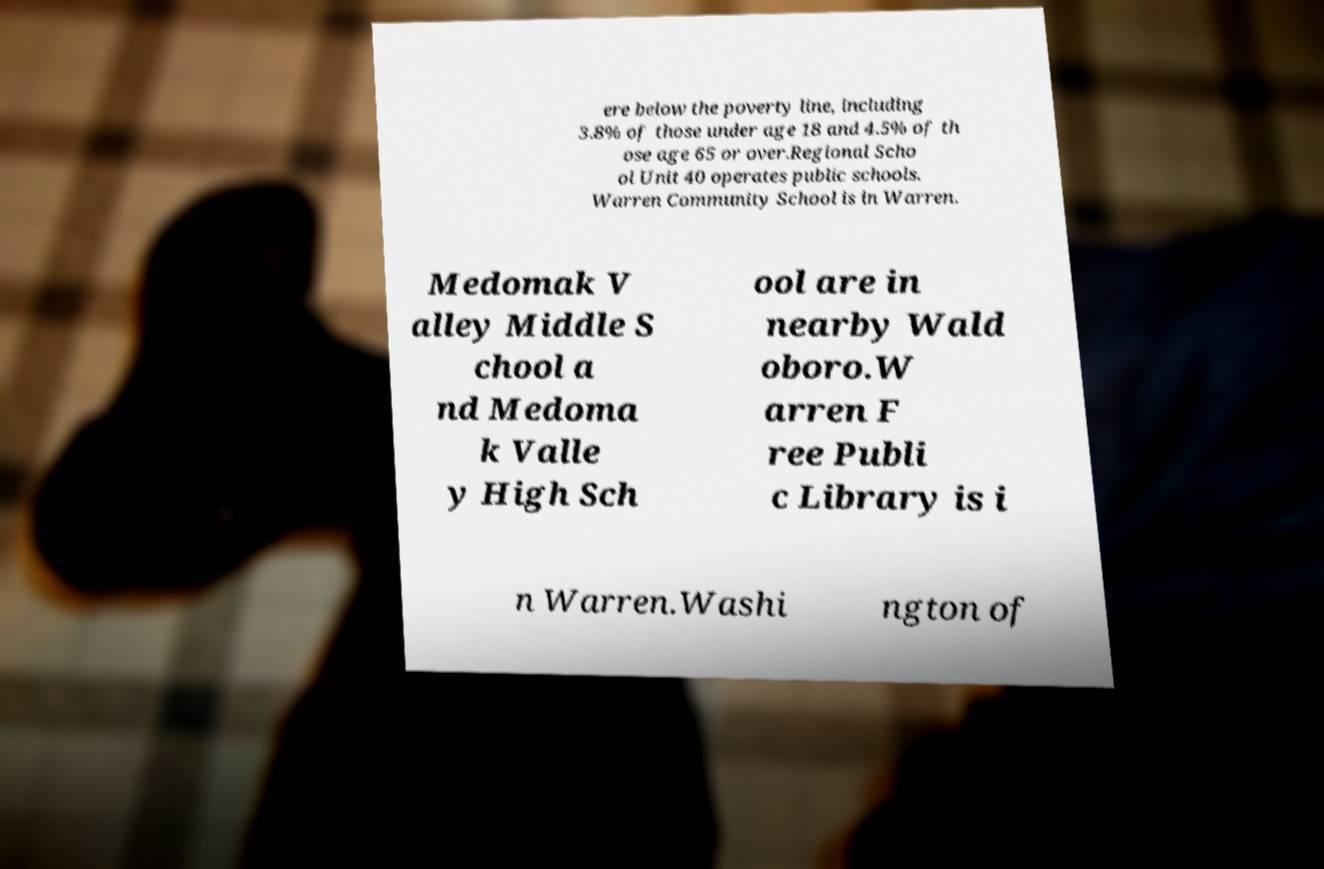Could you assist in decoding the text presented in this image and type it out clearly? ere below the poverty line, including 3.8% of those under age 18 and 4.5% of th ose age 65 or over.Regional Scho ol Unit 40 operates public schools. Warren Community School is in Warren. Medomak V alley Middle S chool a nd Medoma k Valle y High Sch ool are in nearby Wald oboro.W arren F ree Publi c Library is i n Warren.Washi ngton of 